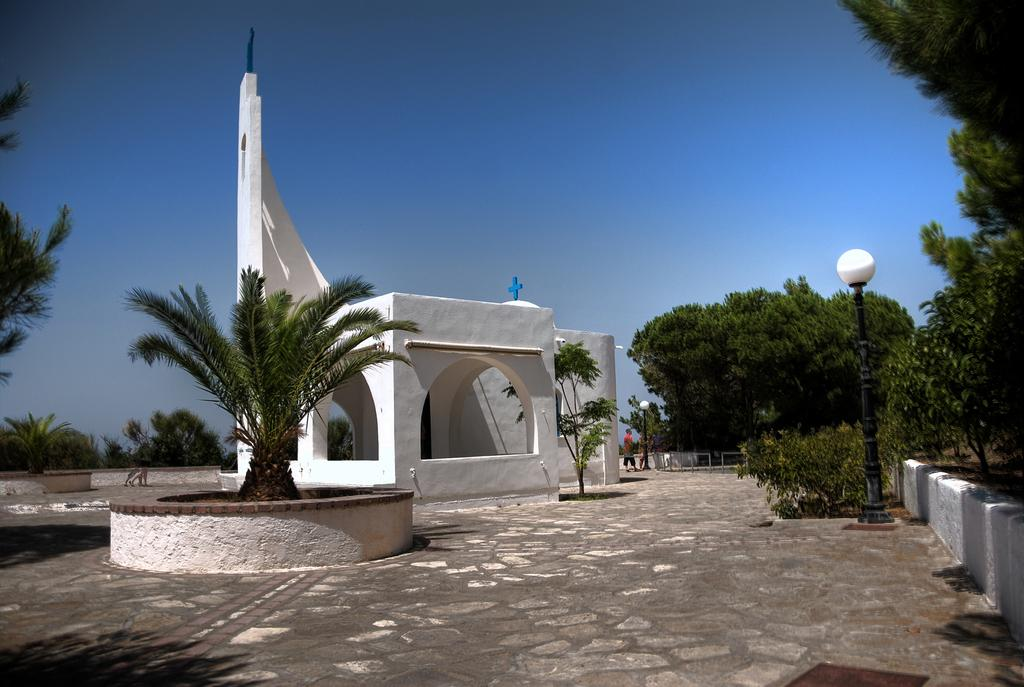What is the main structure in the picture? There is a house in the picture. What is the woman in the picture doing? A woman is walking around in the picture. What type of natural elements can be seen in the picture? There are trees in the picture. What type of punishment is the woman receiving in the picture? There is no indication in the image that the woman is receiving any punishment; she is simply walking around. What is the woman using to water the trees in the picture? There is no hose or any other watering tool visible in the image. 